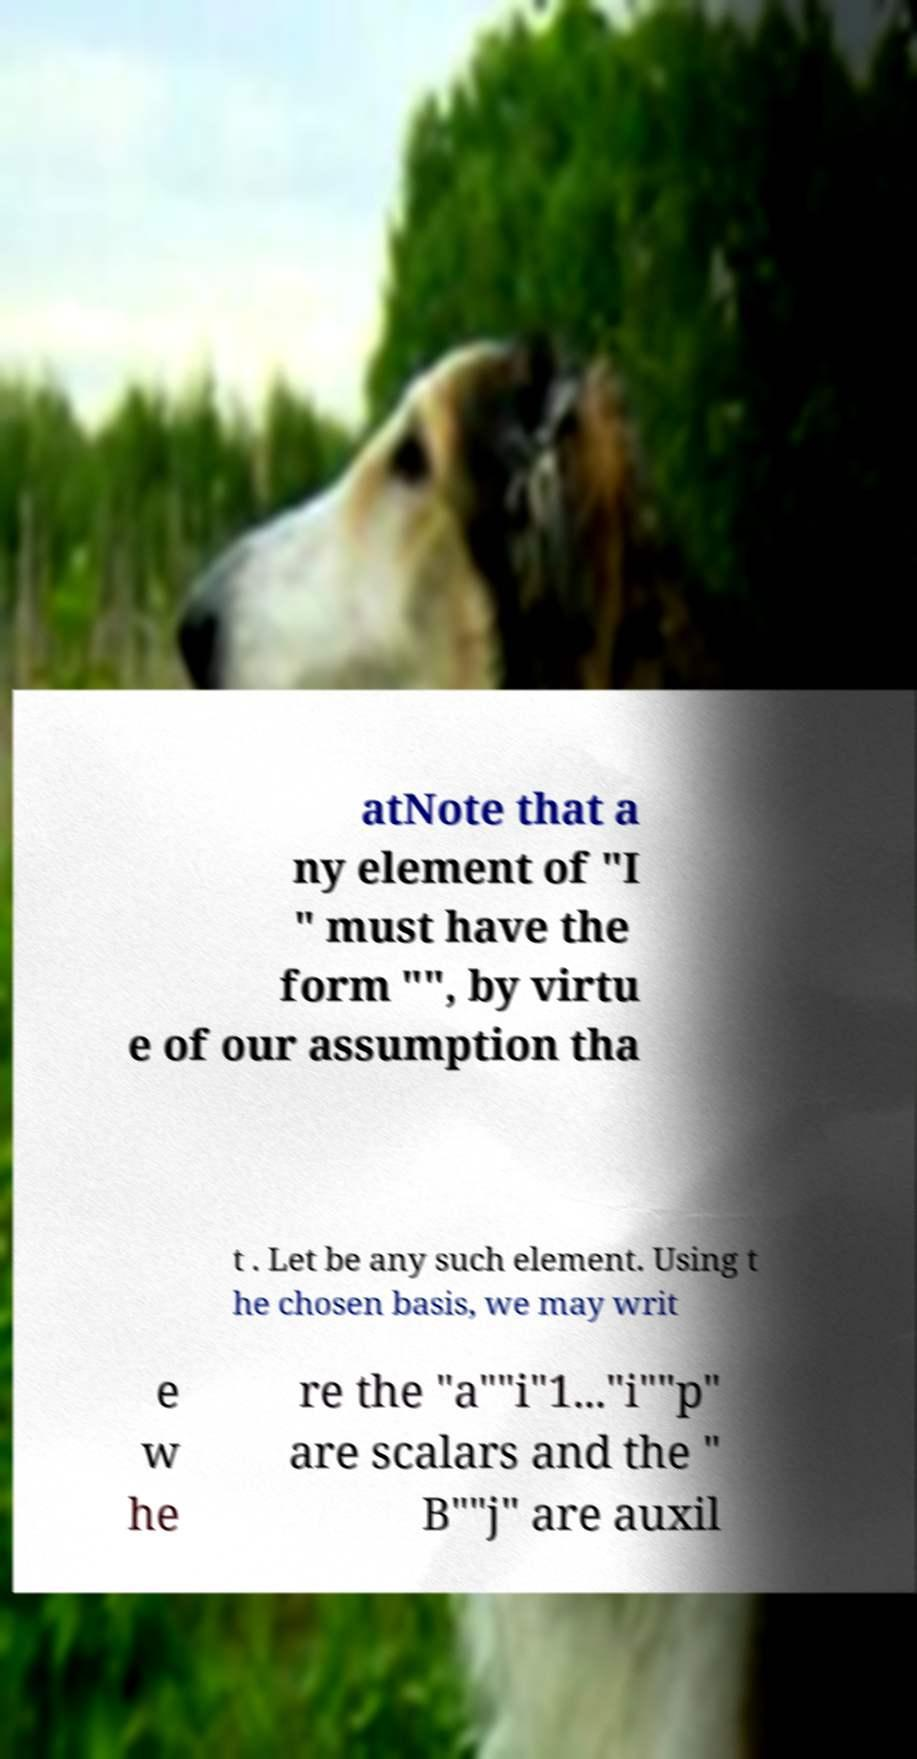Can you accurately transcribe the text from the provided image for me? atNote that a ny element of "I " must have the form "", by virtu e of our assumption tha t . Let be any such element. Using t he chosen basis, we may writ e w he re the "a""i"1..."i""p" are scalars and the " B""j" are auxil 